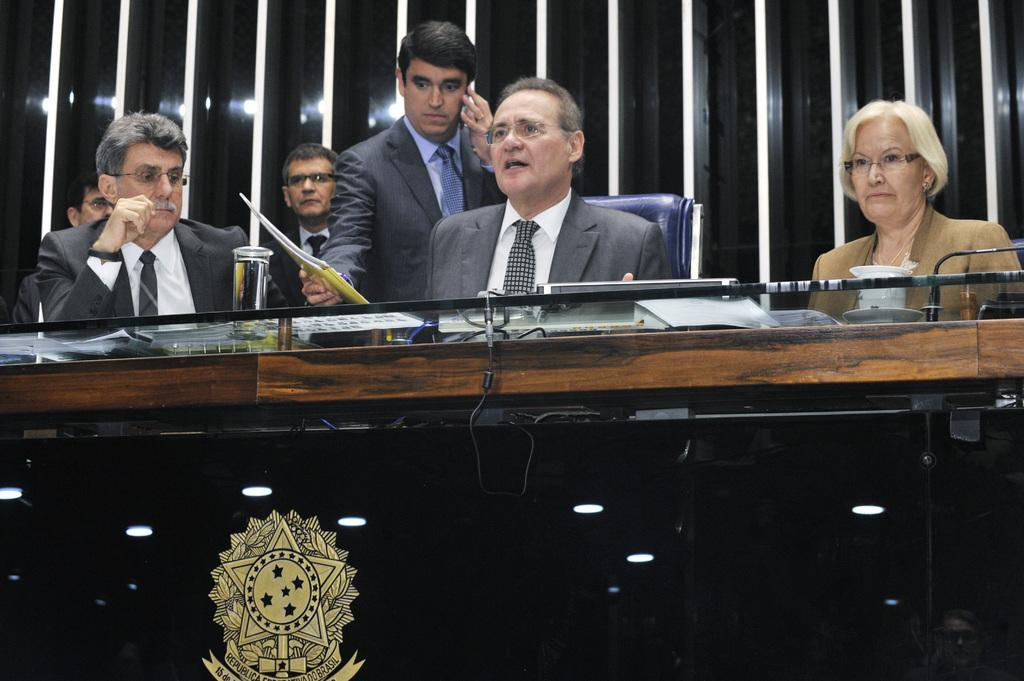What type of table is in the image? There is a wooden table in the image. Can you describe any specific features of the wooden table? The wooden table has a logo at the bottom. Who or what can be seen in the image besides the wooden table? There are persons in the image. What is visible in the background of the image? There is a wooden wall in the background of the image. What type of calculator is being used by the persons in the image? There is no calculator present in the image; the focus is on the wooden table and the persons. What industry is represented by the persons in the image? The image does not provide any information about the industry associated with the persons. 